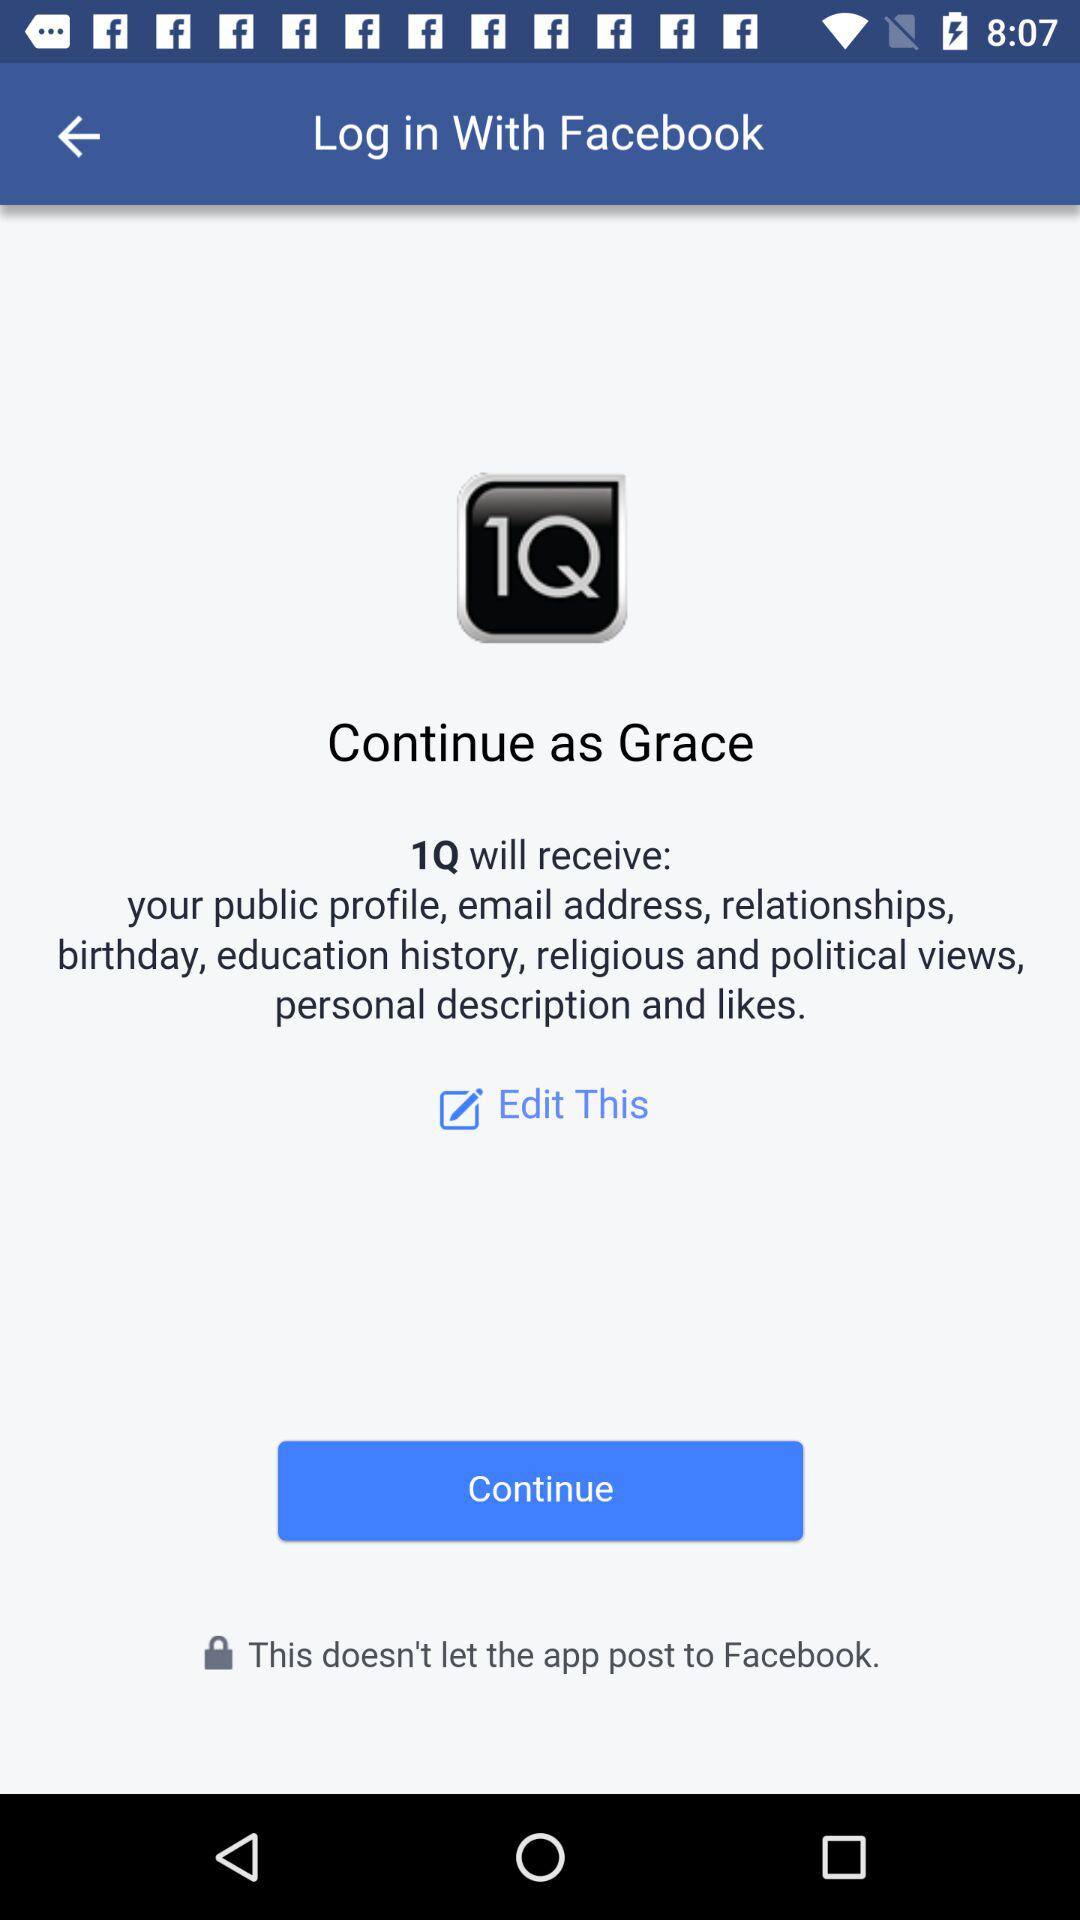What is the user name? The user name is Grace. 